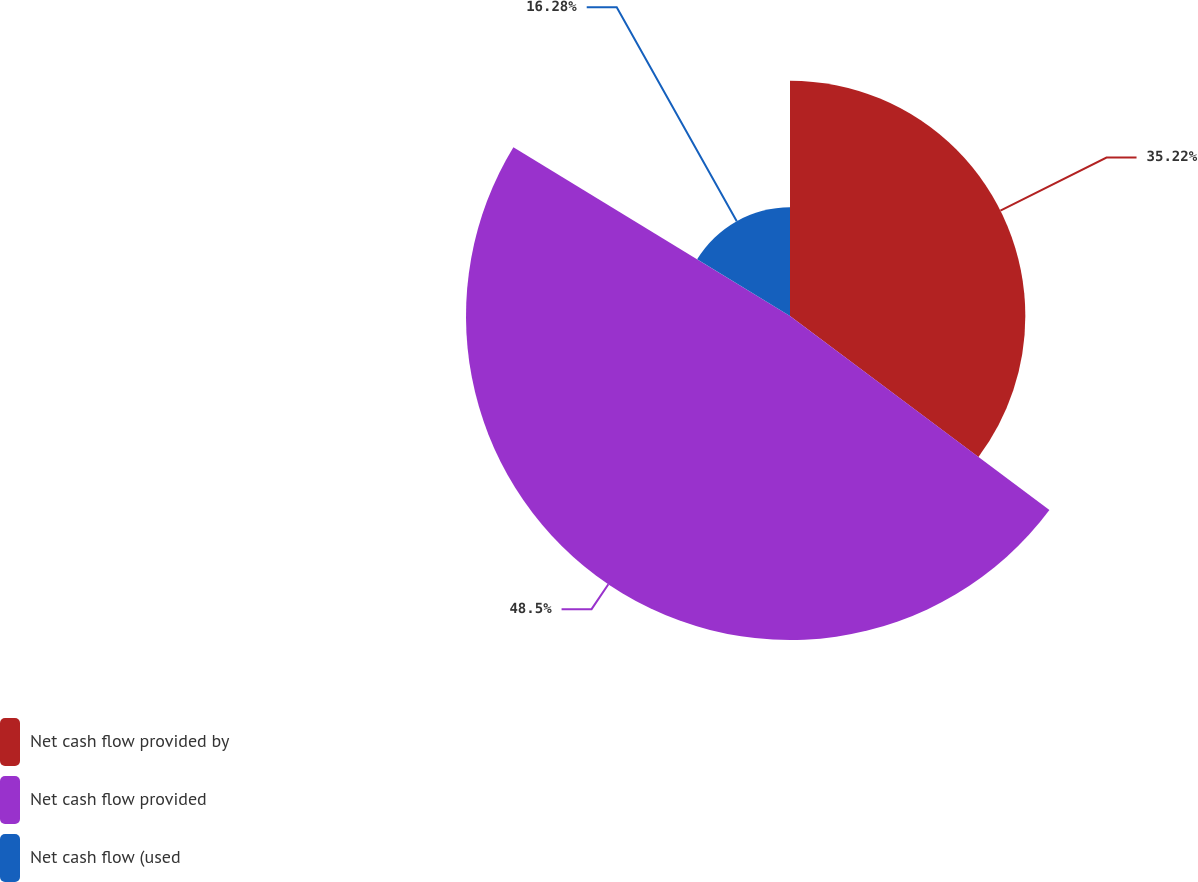Convert chart. <chart><loc_0><loc_0><loc_500><loc_500><pie_chart><fcel>Net cash flow provided by<fcel>Net cash flow provided<fcel>Net cash flow (used<nl><fcel>35.22%<fcel>48.49%<fcel>16.28%<nl></chart> 